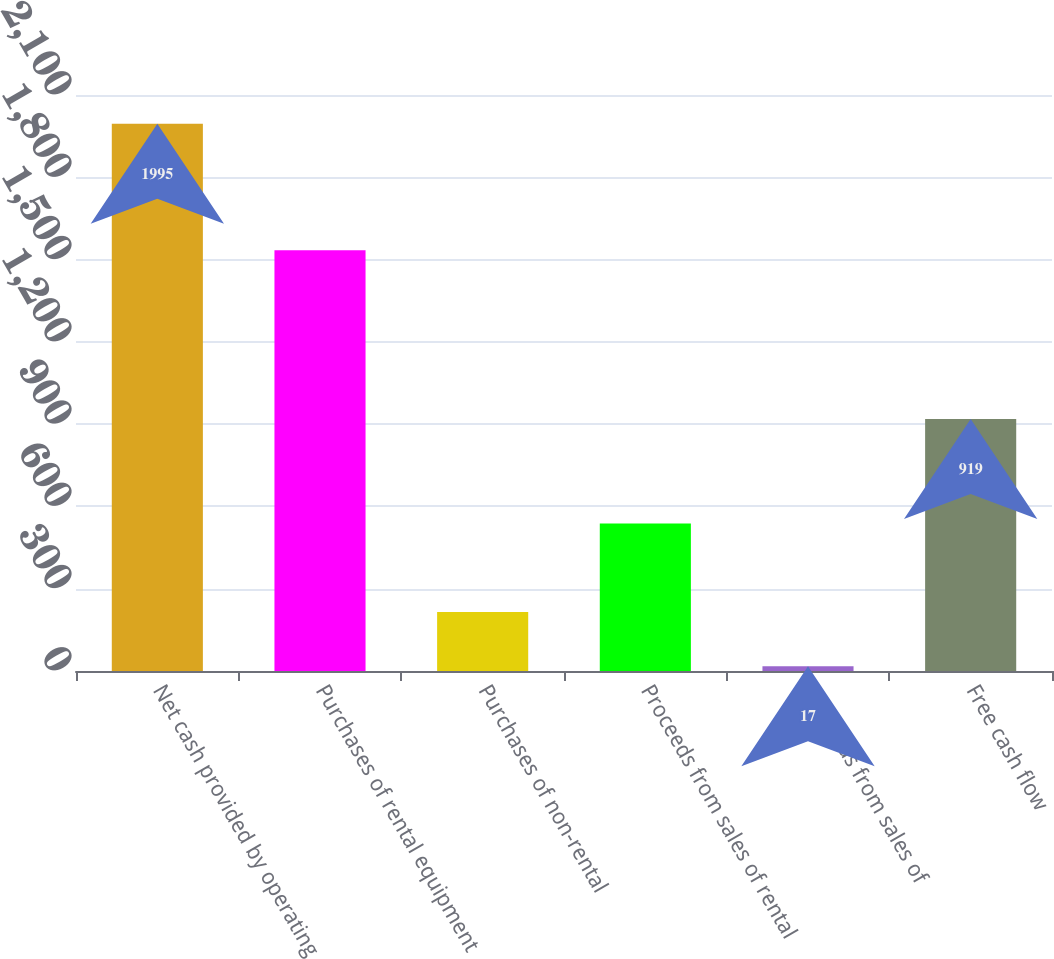Convert chart to OTSL. <chart><loc_0><loc_0><loc_500><loc_500><bar_chart><fcel>Net cash provided by operating<fcel>Purchases of rental equipment<fcel>Purchases of non-rental<fcel>Proceeds from sales of rental<fcel>Proceeds from sales of<fcel>Free cash flow<nl><fcel>1995<fcel>1534<fcel>214.8<fcel>538<fcel>17<fcel>919<nl></chart> 